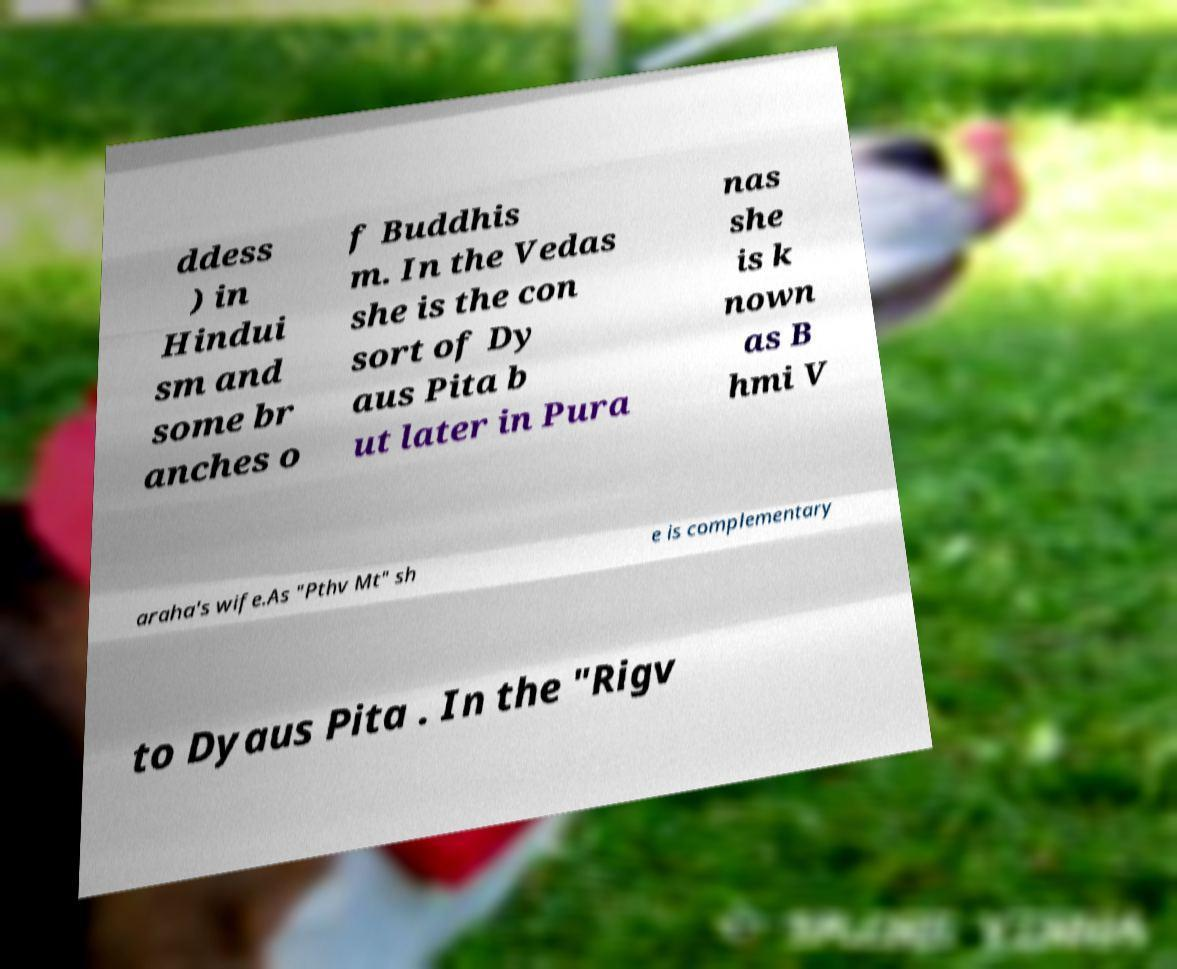Can you accurately transcribe the text from the provided image for me? ddess ) in Hindui sm and some br anches o f Buddhis m. In the Vedas she is the con sort of Dy aus Pita b ut later in Pura nas she is k nown as B hmi V araha's wife.As "Pthv Mt" sh e is complementary to Dyaus Pita . In the "Rigv 